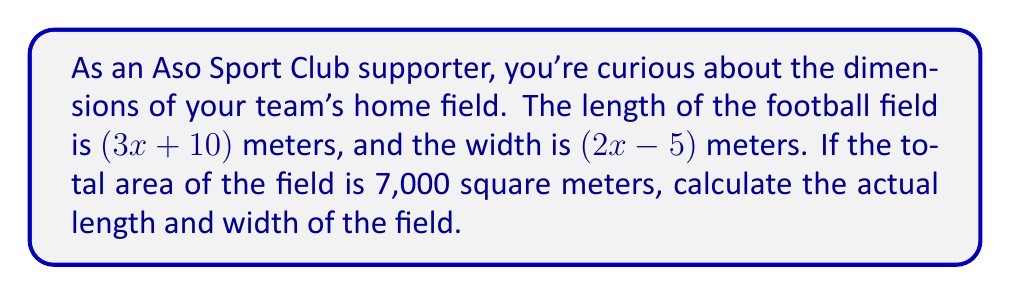What is the answer to this math problem? Let's approach this step-by-step:

1) The area of a rectangle is given by length × width. So we can set up the equation:

   $$(3x + 10)(2x - 5) = 7000$$

2) Let's expand the left side of the equation:
   
   $$(3x + 10)(2x - 5) = 6x^2 - 15x + 20x - 50 = 6x^2 + 5x - 50$$

3) Now our equation looks like this:

   $$6x^2 + 5x - 50 = 7000$$

4) Subtract 7000 from both sides:

   $$6x^2 + 5x - 7050 = 0$$

5) This is a quadratic equation. We can solve it using the quadratic formula: 
   
   $$x = \frac{-b \pm \sqrt{b^2 - 4ac}}{2a}$$

   where $a = 6$, $b = 5$, and $c = -7050$

6) Plugging in these values:

   $$x = \frac{-5 \pm \sqrt{5^2 - 4(6)(-7050)}}{2(6)}$$
   
   $$= \frac{-5 \pm \sqrt{25 + 169200}}{12}$$
   
   $$= \frac{-5 \pm \sqrt{169225}}{12}$$
   
   $$= \frac{-5 \pm 411.37}{12}$$

7) This gives us two solutions:
   
   $$x = \frac{-5 + 411.37}{12} \approx 33.86$$ or $$x = \frac{-5 - 411.37}{12} \approx -34.70$$

8) Since length and width can't be negative, we use $x \approx 33.86$

9) Now we can calculate the length and width:

   Length: $3x + 10 = 3(33.86) + 10 \approx 111.58$ meters
   Width: $2x - 5 = 2(33.86) - 5 \approx 62.72$ meters
Answer: The actual dimensions of the Aso Sport Club football field are approximately 111.58 meters long and 62.72 meters wide. 